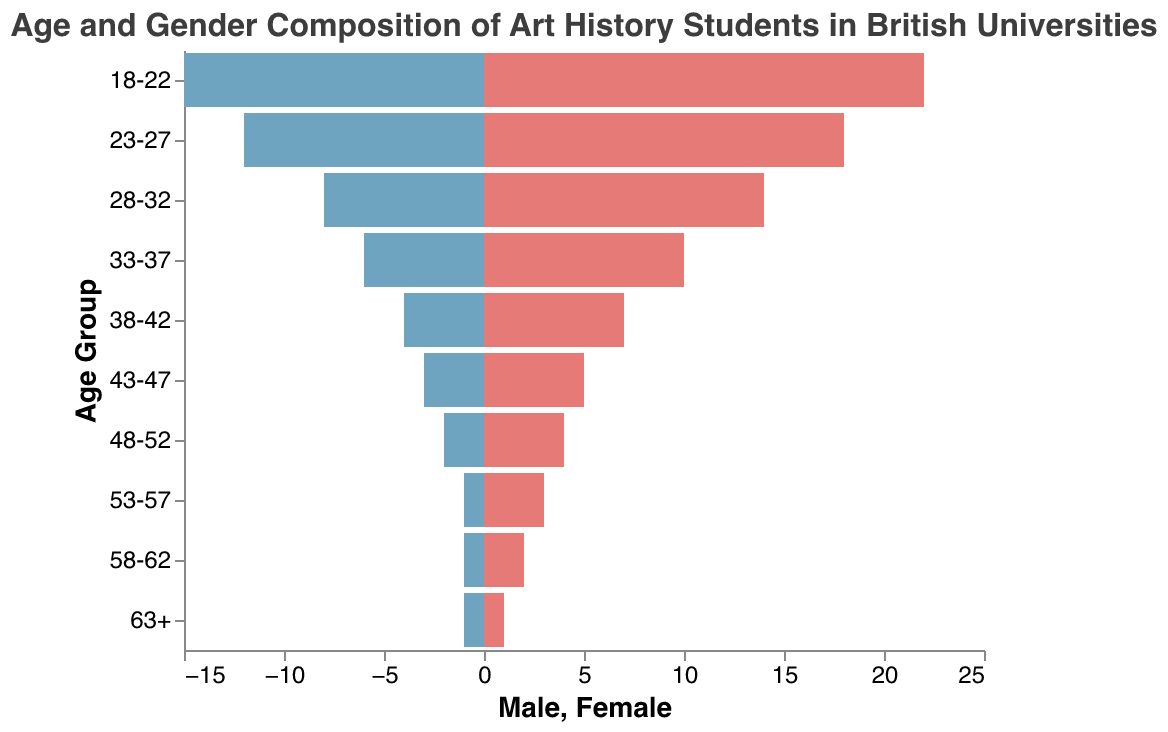What is the age group with the highest number of students? The figure shows the number of male and female students for each age group. The age group 18-22 has the highest number of students with 15 male and 22 female students, totaling 37.
Answer: 18-22 How many female students are there in the 28-32 age group? Looking at the "28-32" age group in the figure, it is shown that there are 14 female students.
Answer: 14 What is the total number of male students in the age group 43-47? By observing the figure, it is indicated that the "43-47" age group has 3 male students.
Answer: 3 Which age group has an equal number of male and female students? The figure displays that the "63+" age group has 1 male and 1 female student, indicating an equal number.
Answer: 63+ How many more female students are there than male students in the 18-22 age group? In the "18-22" age group, there are 22 female and 15 male students. The number of additional female students is 22 - 15 = 7.
Answer: 7 Calculate the total number of students in the 58-62 age group. The figure shows that the "58-62" age group has 1 male and 2 female students. Adding these gives 1 + 2 = 3 students in total.
Answer: 3 Which gender has more students in the 33-37 age group? The figure shows that in the "33-37" age group, there are 6 male students and 10 female students. Therefore, there are more female students.
Answer: Female What percentage of the "23-27" age group are female students? The "23-27" age group has 12 male and 18 female students, making a total of 30 students. The percentage of female students is (18 / 30) * 100 = 60%.
Answer: 60% What is the overall trend in the number of students as the age increases? Observing the bars, both for males and females, it can be seen that the number of students gradually decreases as the age group increases.
Answer: Decreasing Is there any age group where the number of male students exceeds the number of female students? Reviewing all age groups in the figure, there is no age group where the number of male students exceeds the number of female students.
Answer: No 